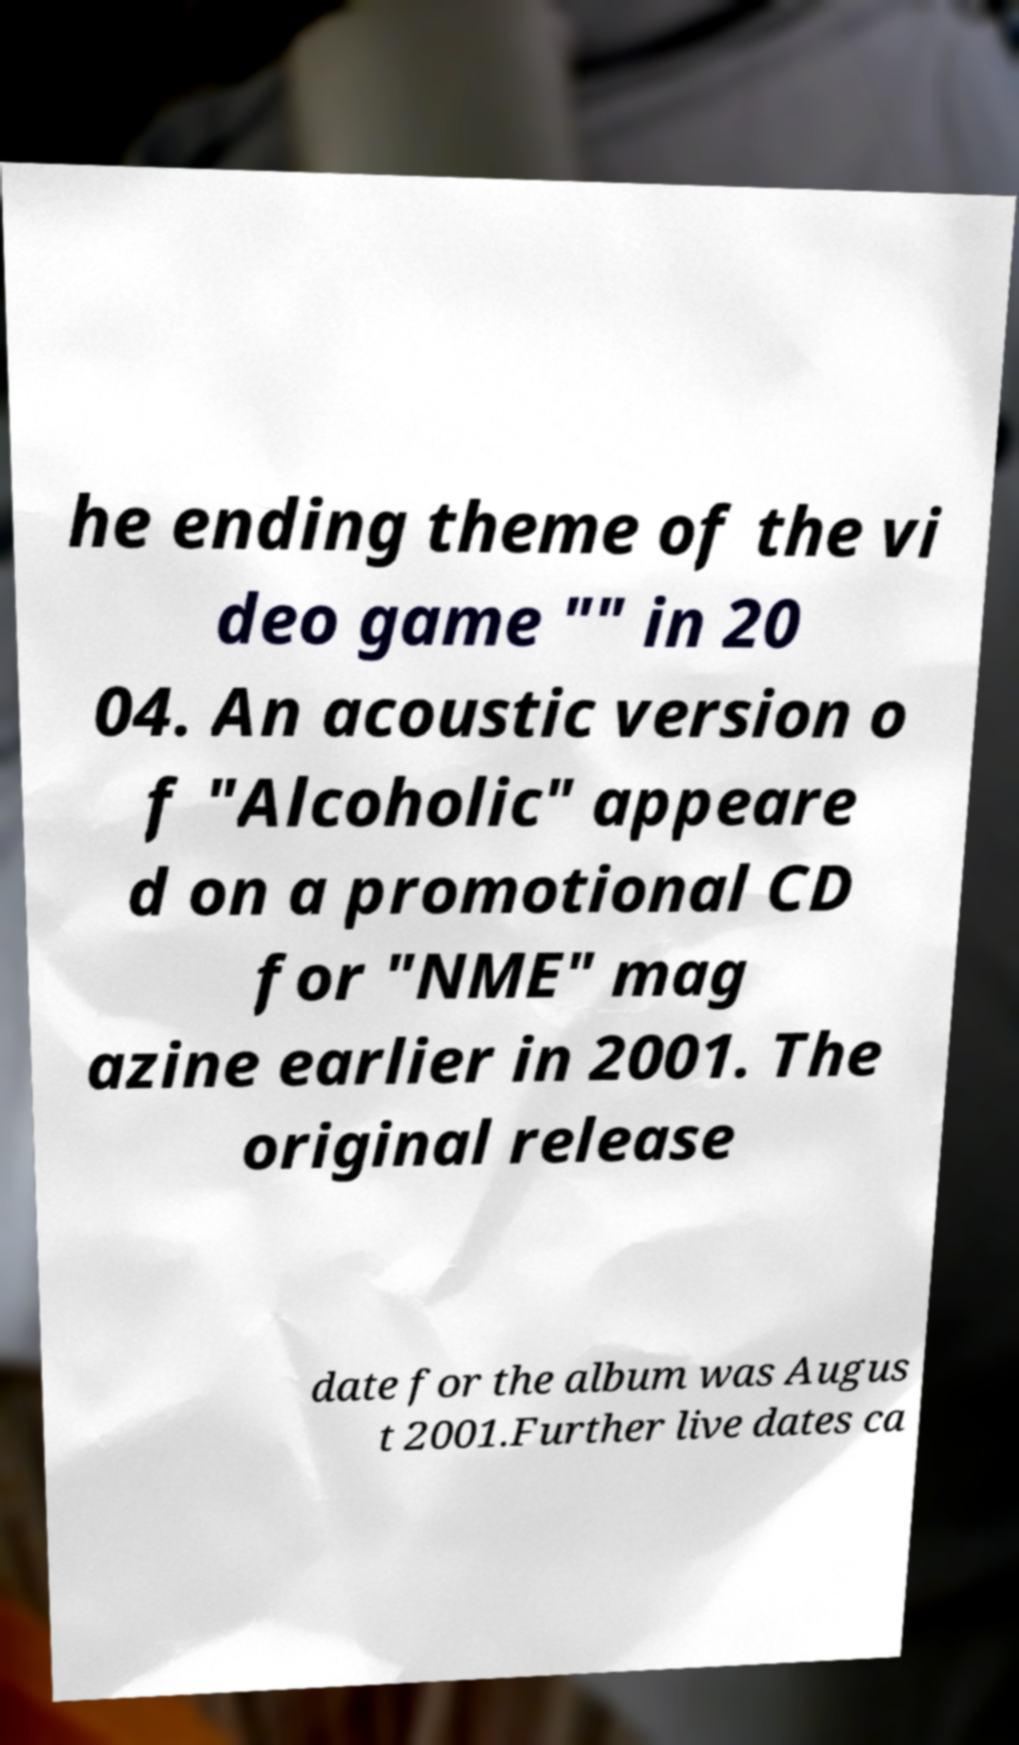Please identify and transcribe the text found in this image. he ending theme of the vi deo game "" in 20 04. An acoustic version o f "Alcoholic" appeare d on a promotional CD for "NME" mag azine earlier in 2001. The original release date for the album was Augus t 2001.Further live dates ca 